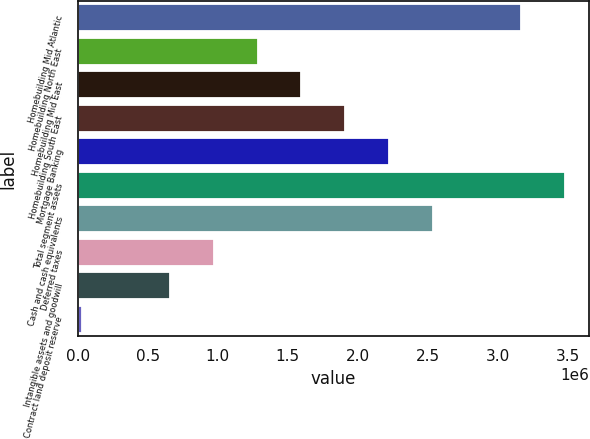Convert chart to OTSL. <chart><loc_0><loc_0><loc_500><loc_500><bar_chart><fcel>Homebuilding Mid Atlantic<fcel>Homebuilding North East<fcel>Homebuilding Mid East<fcel>Homebuilding South East<fcel>Mortgage Banking<fcel>Total segment assets<fcel>Cash and cash equivalents<fcel>Deferred taxes<fcel>Intangible assets and goodwill<fcel>Contract land deposit reserve<nl><fcel>3.16593e+06<fcel>1.2839e+06<fcel>1.59757e+06<fcel>1.91125e+06<fcel>2.22492e+06<fcel>3.4796e+06<fcel>2.53859e+06<fcel>970231<fcel>656559<fcel>29216<nl></chart> 